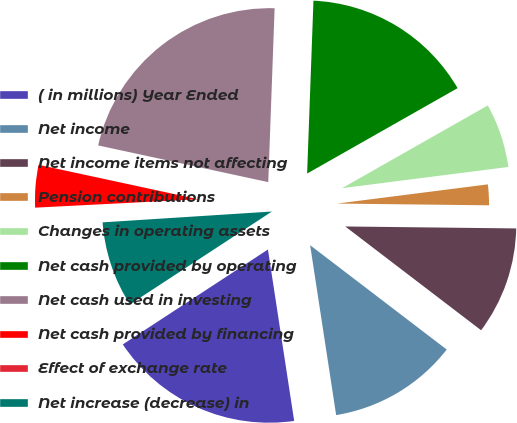Convert chart. <chart><loc_0><loc_0><loc_500><loc_500><pie_chart><fcel>( in millions) Year Ended<fcel>Net income<fcel>Net income items not affecting<fcel>Pension contributions<fcel>Changes in operating assets<fcel>Net cash provided by operating<fcel>Net cash used in investing<fcel>Net cash provided by financing<fcel>Effect of exchange rate<fcel>Net increase (decrease) in<nl><fcel>18.2%<fcel>12.2%<fcel>10.2%<fcel>2.2%<fcel>6.2%<fcel>16.2%<fcel>22.2%<fcel>4.2%<fcel>0.2%<fcel>8.2%<nl></chart> 